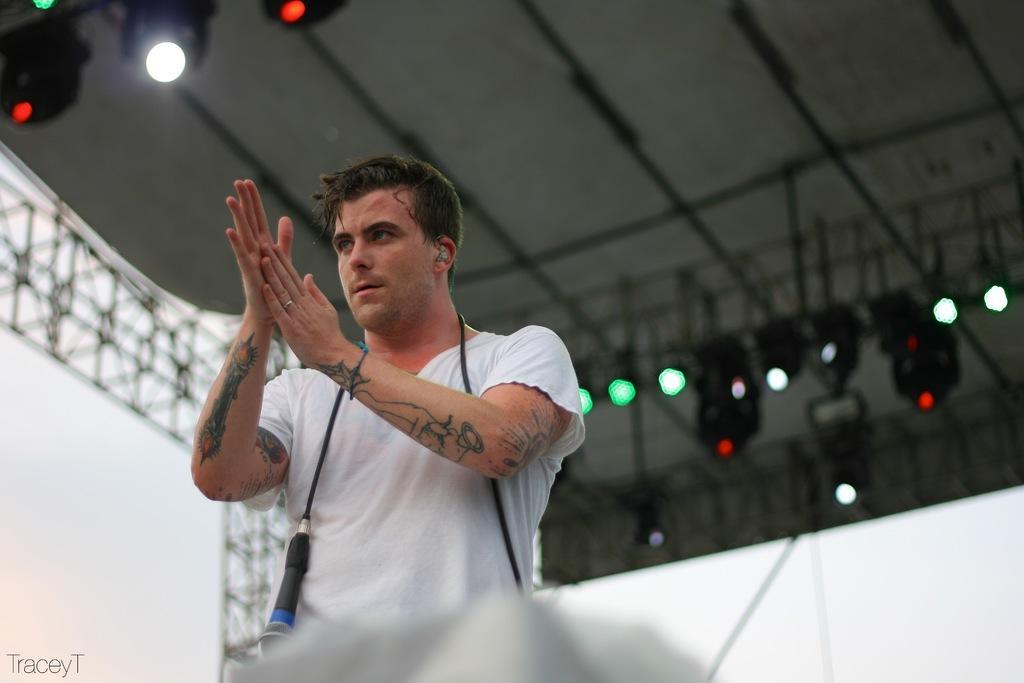Can you describe this image briefly? In this image in front there is a person and he is clapping. In the background of the image there are lights. There is a wall. 